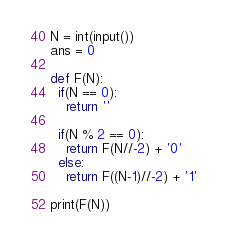<code> <loc_0><loc_0><loc_500><loc_500><_Python_>N = int(input())
ans = 0

def F(N):
  if(N == 0):
    return ''
  
  if(N % 2 == 0):
    return F(N//-2) + '0'
  else:
    return F((N-1)//-2) + '1'

print(F(N))</code> 